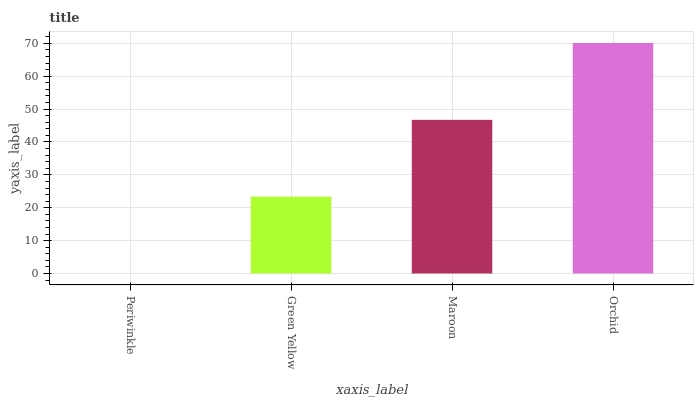Is Periwinkle the minimum?
Answer yes or no. Yes. Is Orchid the maximum?
Answer yes or no. Yes. Is Green Yellow the minimum?
Answer yes or no. No. Is Green Yellow the maximum?
Answer yes or no. No. Is Green Yellow greater than Periwinkle?
Answer yes or no. Yes. Is Periwinkle less than Green Yellow?
Answer yes or no. Yes. Is Periwinkle greater than Green Yellow?
Answer yes or no. No. Is Green Yellow less than Periwinkle?
Answer yes or no. No. Is Maroon the high median?
Answer yes or no. Yes. Is Green Yellow the low median?
Answer yes or no. Yes. Is Periwinkle the high median?
Answer yes or no. No. Is Periwinkle the low median?
Answer yes or no. No. 